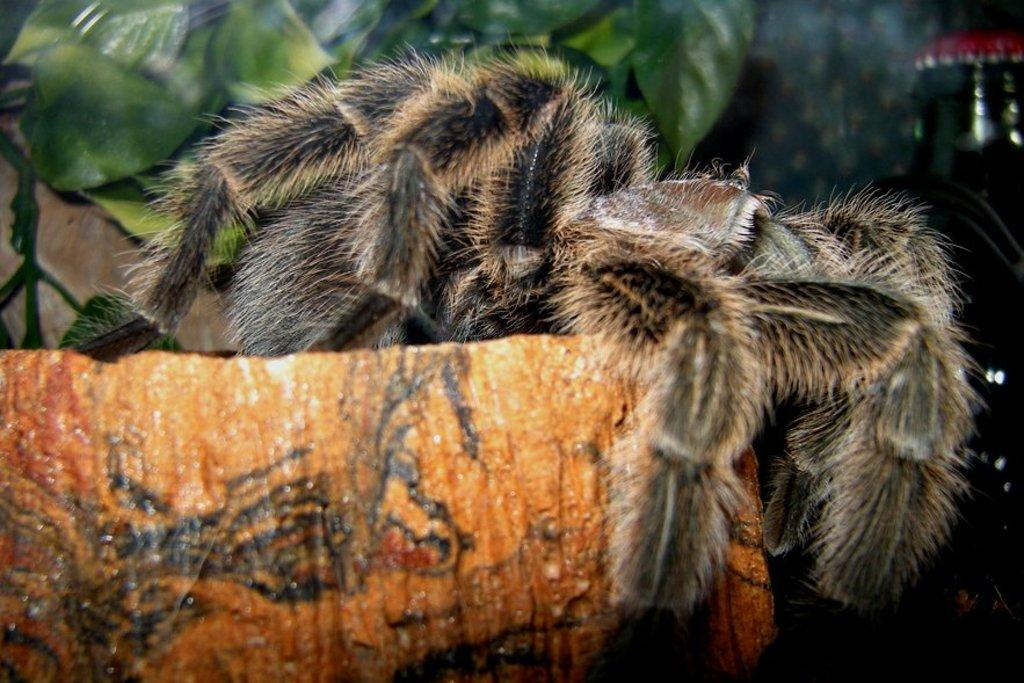What is the spider positioned on in the image? There is a spider on an orange object in the image. What type of vegetation can be seen in the background of the image? There are green leaves in the background. What other object can be seen in the background of the image? There is a bottle in the background. What type of sock is the beggar wearing in the image? There is no beggar or sock present in the image. What type of crown is the queen wearing in the image? There is no queen present in the image. 